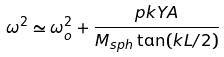Convert formula to latex. <formula><loc_0><loc_0><loc_500><loc_500>\omega ^ { 2 } \simeq \omega _ { o } ^ { 2 } + \frac { p k Y A } { M _ { s p h } \tan ( k L / 2 ) }</formula> 